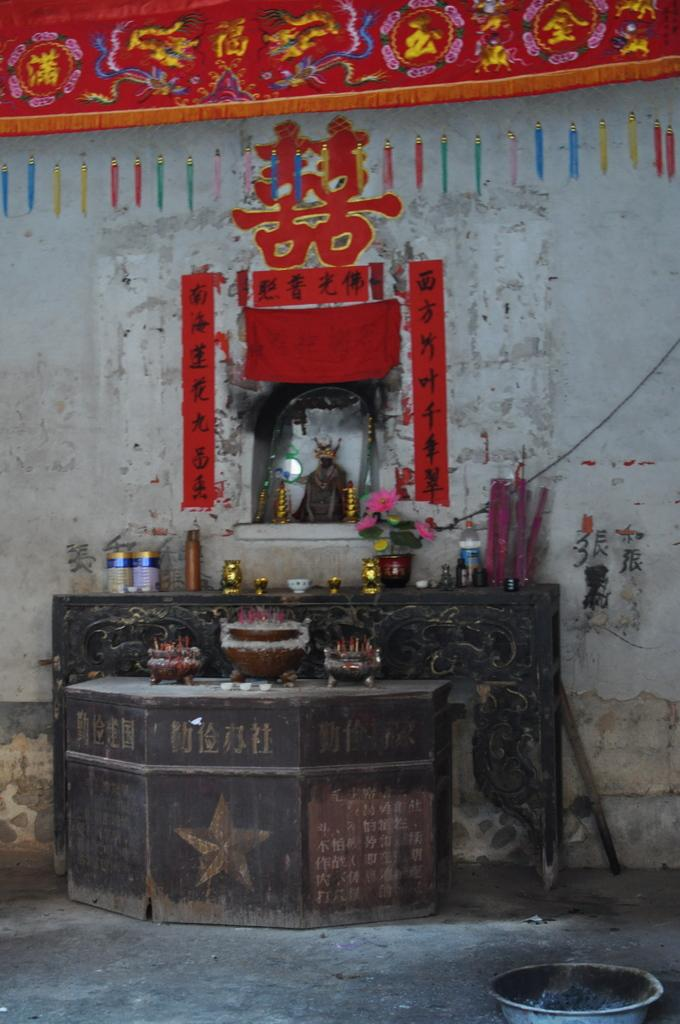What is written or displayed on the wall in the image? There is text on the wall in the image. What else can be seen on the wall besides the text? There are clothes on the wall in the image. What can be found on the table in the image? There are objects on a table in the image. What type of container is visible in the image? There is a bowl in the image. How many legs can be seen on the table in the image? There are no legs visible in the image; the table is not shown. Is there a cellar depicted in the image? There is no cellar present in the image. 